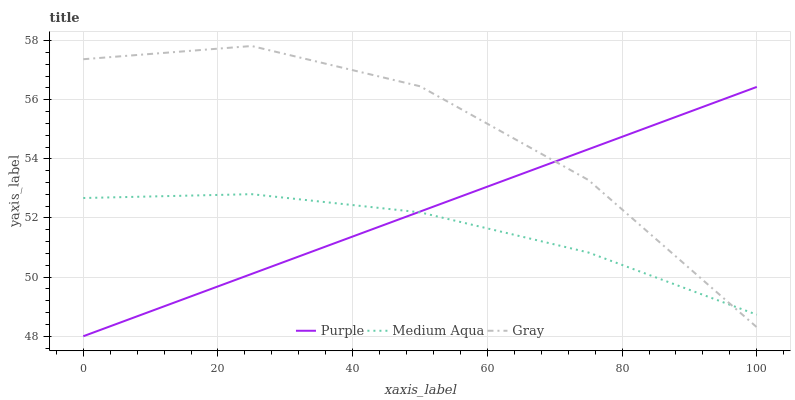Does Medium Aqua have the minimum area under the curve?
Answer yes or no. Yes. Does Gray have the maximum area under the curve?
Answer yes or no. Yes. Does Gray have the minimum area under the curve?
Answer yes or no. No. Does Medium Aqua have the maximum area under the curve?
Answer yes or no. No. Is Purple the smoothest?
Answer yes or no. Yes. Is Gray the roughest?
Answer yes or no. Yes. Is Medium Aqua the smoothest?
Answer yes or no. No. Is Medium Aqua the roughest?
Answer yes or no. No. Does Purple have the lowest value?
Answer yes or no. Yes. Does Gray have the lowest value?
Answer yes or no. No. Does Gray have the highest value?
Answer yes or no. Yes. Does Medium Aqua have the highest value?
Answer yes or no. No. Does Purple intersect Medium Aqua?
Answer yes or no. Yes. Is Purple less than Medium Aqua?
Answer yes or no. No. Is Purple greater than Medium Aqua?
Answer yes or no. No. 